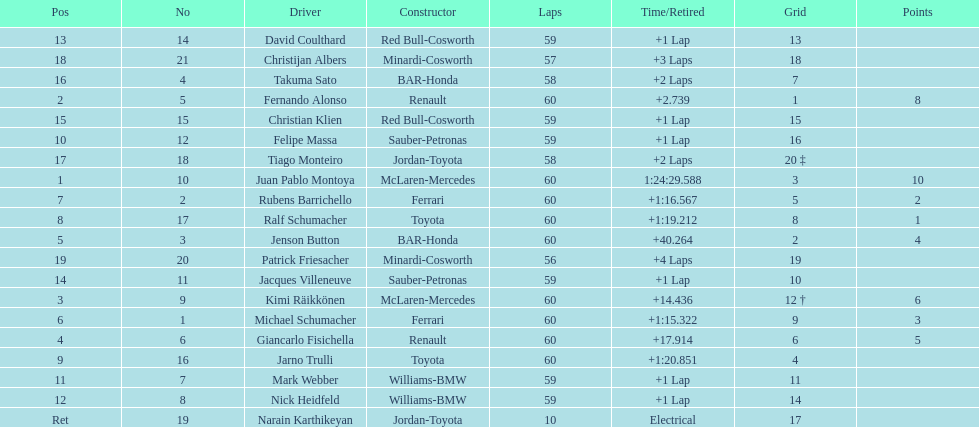Which driver has the least amount of points? Ralf Schumacher. 